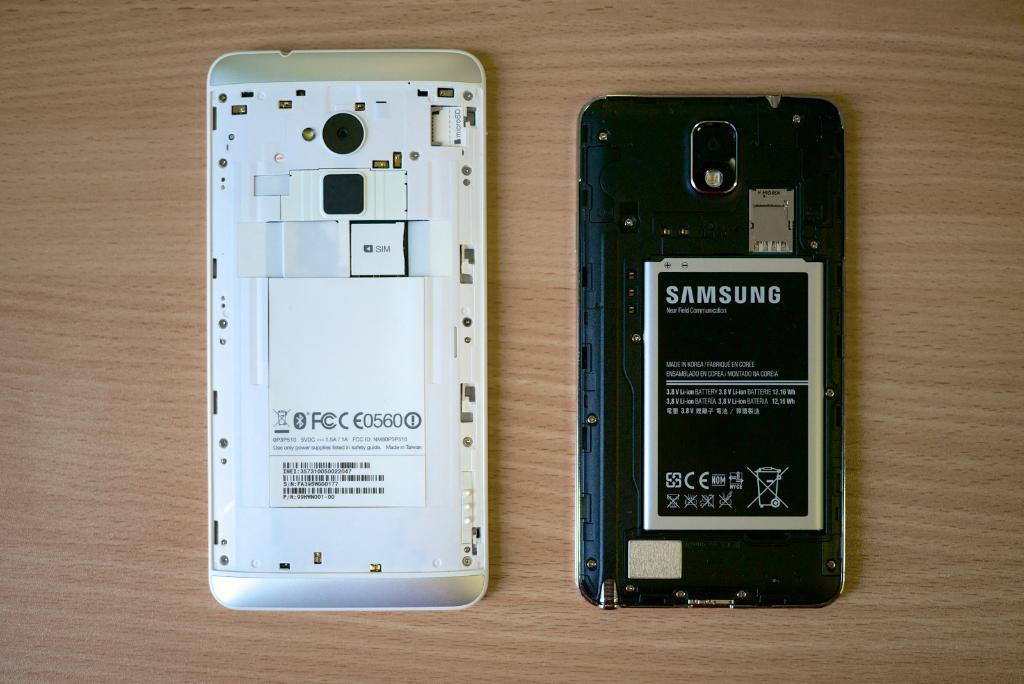<image>
Relay a brief, clear account of the picture shown. Two Samsung phones sit side by side with the backs removed. 